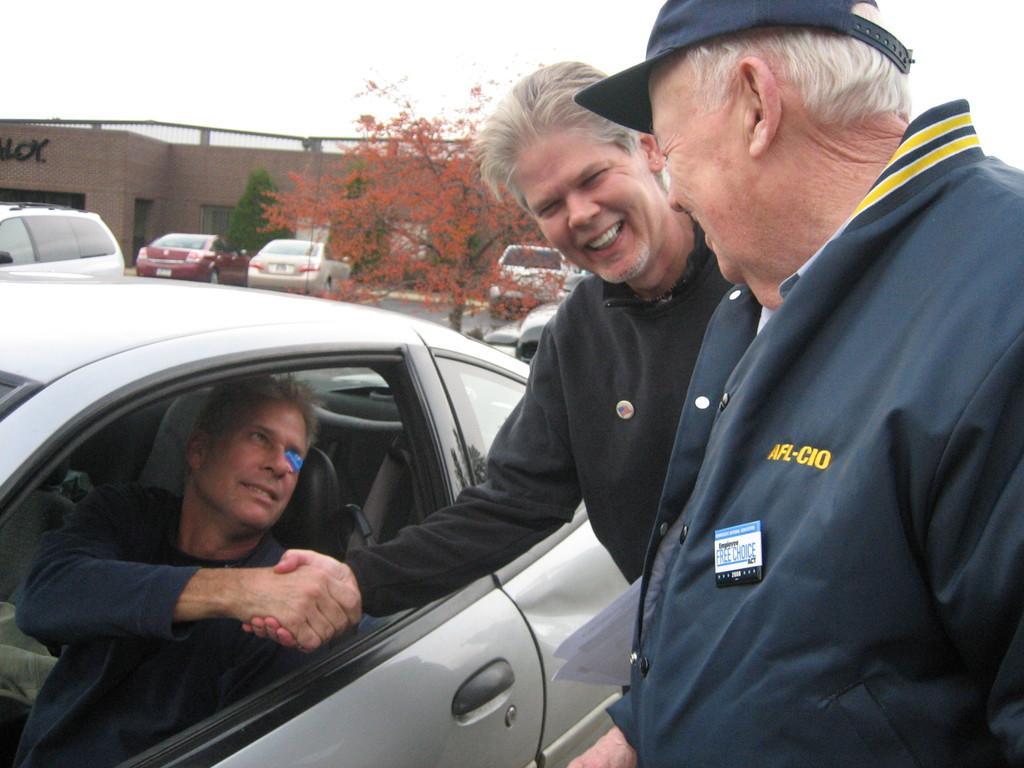Please provide a concise description of this image. A person in the car. And on the right there are two men standing and laughing. In the background we can see a building,few vehicles and a tree and a sky. 